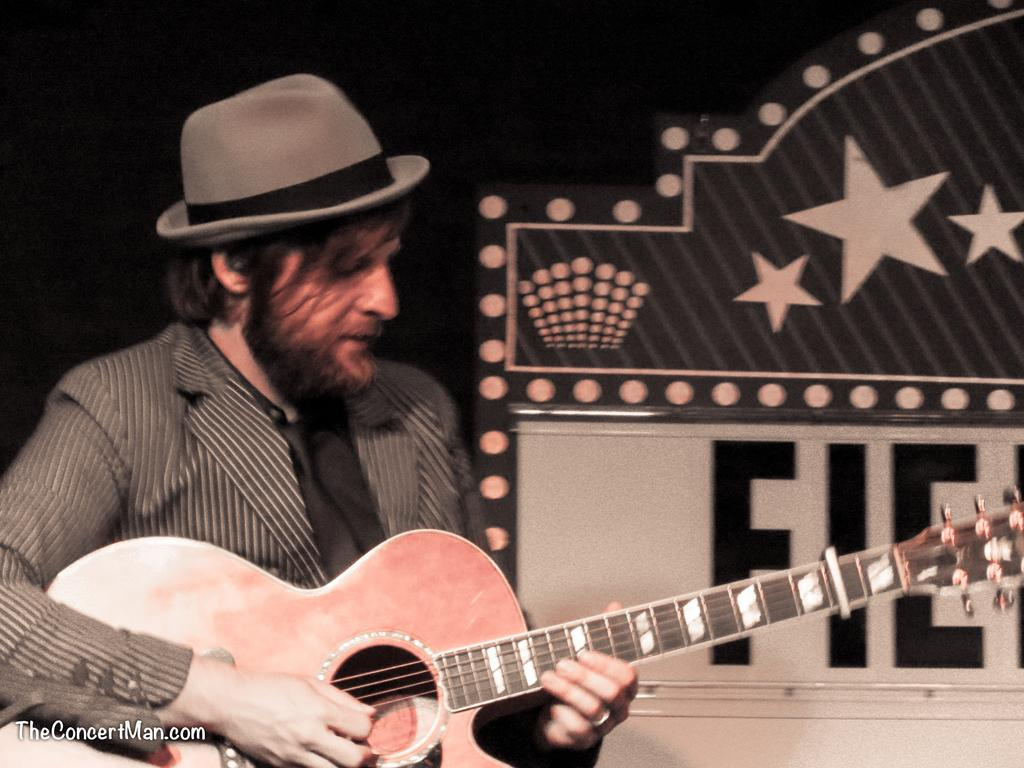What is the man in the image doing? The man is playing a guitar in the image. What is the man wearing on his upper body? The man is wearing a black shirt in the image. What type of clothing is the man wearing on his head? The man is wearing a hat in the image. What type of clothing is the man wearing on his lower body? The man is wearing a suit in the image. What can be seen in the background of the image? There is a banner in the background of the image. How many buttons can be seen on the man's shirt in the image? There is no mention of buttons on the man's shirt in the image; he is wearing a black shirt. What type of food is the man biting into in the image? There is no food present in the image; the man is playing a guitar. 